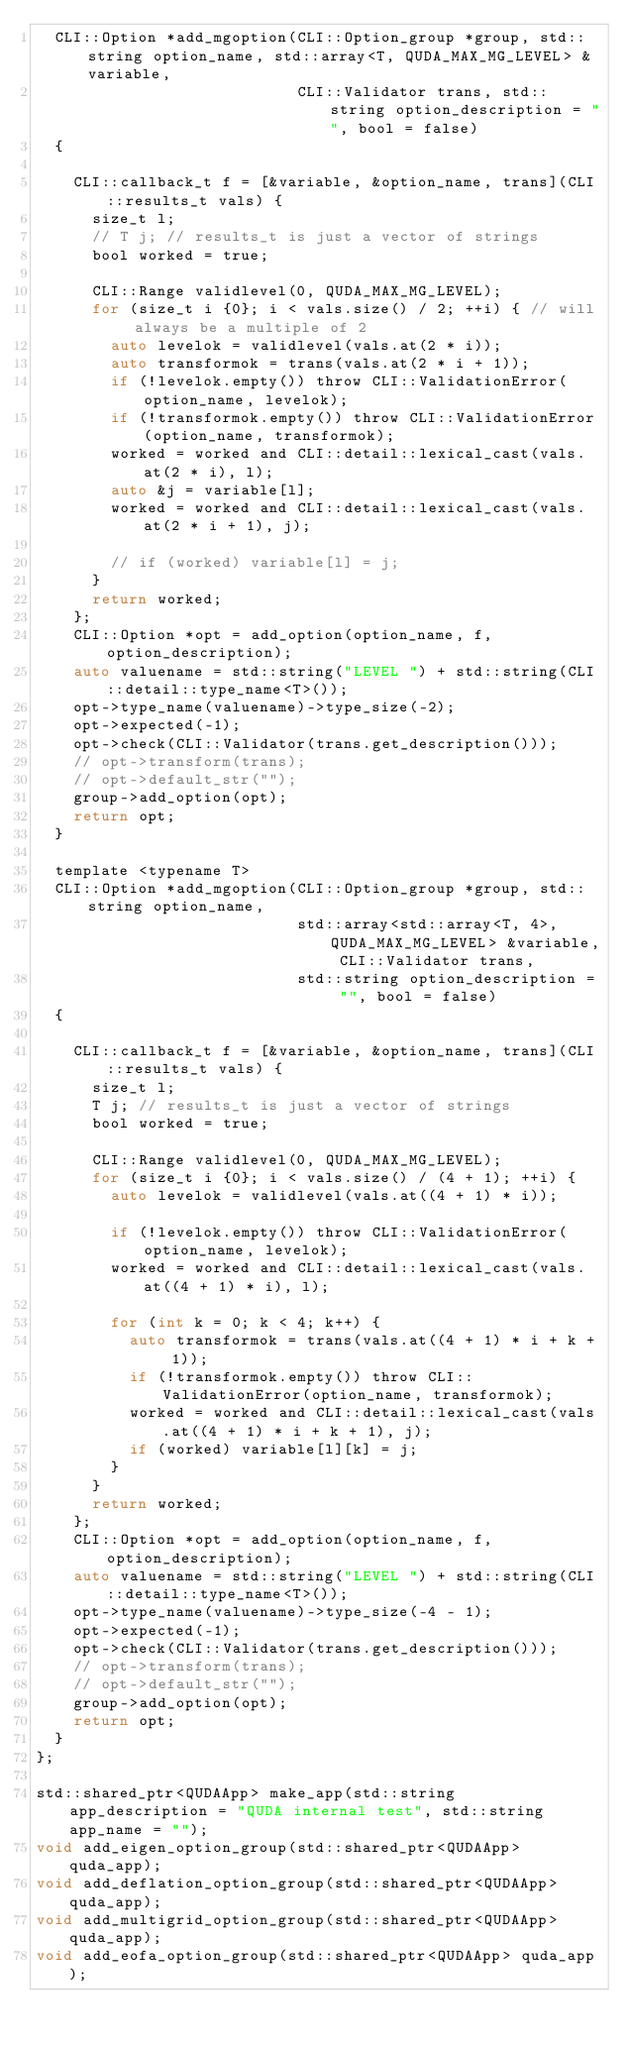Convert code to text. <code><loc_0><loc_0><loc_500><loc_500><_C_>  CLI::Option *add_mgoption(CLI::Option_group *group, std::string option_name, std::array<T, QUDA_MAX_MG_LEVEL> &variable,
                            CLI::Validator trans, std::string option_description = "", bool = false)
  {

    CLI::callback_t f = [&variable, &option_name, trans](CLI::results_t vals) {
      size_t l;
      // T j; // results_t is just a vector of strings
      bool worked = true;

      CLI::Range validlevel(0, QUDA_MAX_MG_LEVEL);
      for (size_t i {0}; i < vals.size() / 2; ++i) { // will always be a multiple of 2
        auto levelok = validlevel(vals.at(2 * i));
        auto transformok = trans(vals.at(2 * i + 1));
        if (!levelok.empty()) throw CLI::ValidationError(option_name, levelok);
        if (!transformok.empty()) throw CLI::ValidationError(option_name, transformok);
        worked = worked and CLI::detail::lexical_cast(vals.at(2 * i), l);
        auto &j = variable[l];
        worked = worked and CLI::detail::lexical_cast(vals.at(2 * i + 1), j);

        // if (worked) variable[l] = j;
      }
      return worked;
    };
    CLI::Option *opt = add_option(option_name, f, option_description);
    auto valuename = std::string("LEVEL ") + std::string(CLI::detail::type_name<T>());
    opt->type_name(valuename)->type_size(-2);
    opt->expected(-1);
    opt->check(CLI::Validator(trans.get_description()));
    // opt->transform(trans);
    // opt->default_str("");
    group->add_option(opt);
    return opt;
  }

  template <typename T>
  CLI::Option *add_mgoption(CLI::Option_group *group, std::string option_name,
                            std::array<std::array<T, 4>, QUDA_MAX_MG_LEVEL> &variable, CLI::Validator trans,
                            std::string option_description = "", bool = false)
  {

    CLI::callback_t f = [&variable, &option_name, trans](CLI::results_t vals) {
      size_t l;
      T j; // results_t is just a vector of strings
      bool worked = true;

      CLI::Range validlevel(0, QUDA_MAX_MG_LEVEL);
      for (size_t i {0}; i < vals.size() / (4 + 1); ++i) {
        auto levelok = validlevel(vals.at((4 + 1) * i));

        if (!levelok.empty()) throw CLI::ValidationError(option_name, levelok);
        worked = worked and CLI::detail::lexical_cast(vals.at((4 + 1) * i), l);

        for (int k = 0; k < 4; k++) {
          auto transformok = trans(vals.at((4 + 1) * i + k + 1));
          if (!transformok.empty()) throw CLI::ValidationError(option_name, transformok);
          worked = worked and CLI::detail::lexical_cast(vals.at((4 + 1) * i + k + 1), j);
          if (worked) variable[l][k] = j;
        }
      }
      return worked;
    };
    CLI::Option *opt = add_option(option_name, f, option_description);
    auto valuename = std::string("LEVEL ") + std::string(CLI::detail::type_name<T>());
    opt->type_name(valuename)->type_size(-4 - 1);
    opt->expected(-1);
    opt->check(CLI::Validator(trans.get_description()));
    // opt->transform(trans);
    // opt->default_str("");
    group->add_option(opt);
    return opt;
  }
};

std::shared_ptr<QUDAApp> make_app(std::string app_description = "QUDA internal test", std::string app_name = "");
void add_eigen_option_group(std::shared_ptr<QUDAApp> quda_app);
void add_deflation_option_group(std::shared_ptr<QUDAApp> quda_app);
void add_multigrid_option_group(std::shared_ptr<QUDAApp> quda_app);
void add_eofa_option_group(std::shared_ptr<QUDAApp> quda_app);</code> 